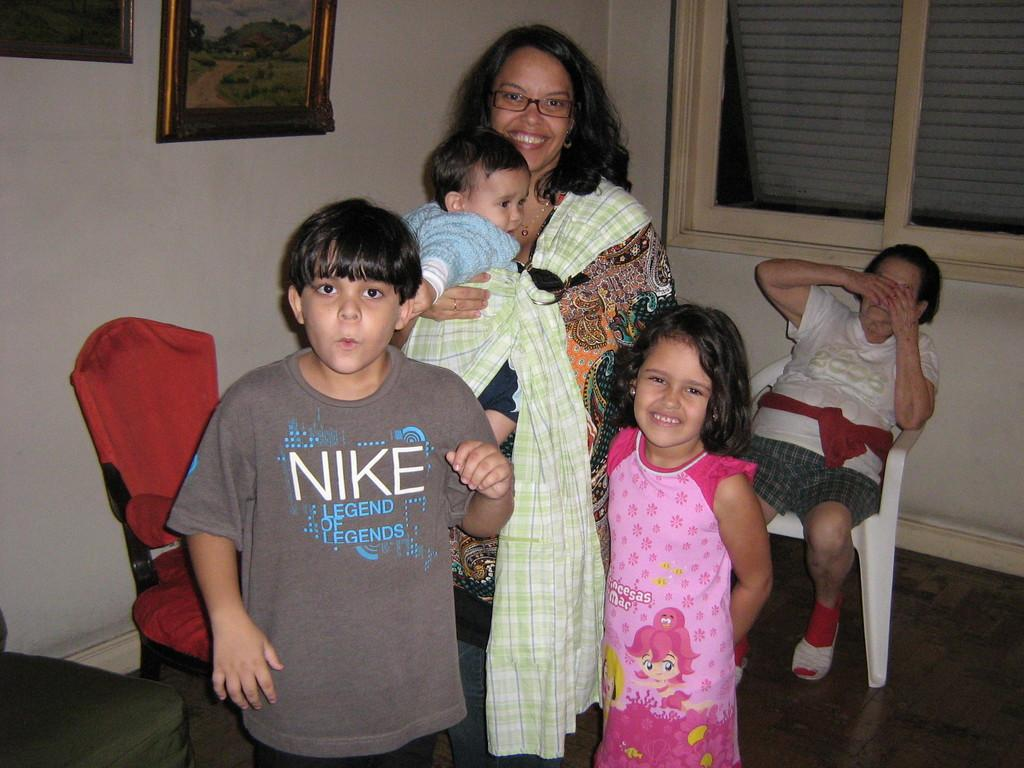How many people are in the image? There are people in the image, but the exact number is not specified. What can be seen in the background of the image? In the background of the image, there is a wall, chairs, a frame, windows, and other objects. Can you describe the object on the left side of the image? The object on the left side of the image is not specified in the facts. What might be used for sitting or resting in the image? Chairs are present in the background of the image, which might be used for sitting or resting. What type of oatmeal is being served on the table in the image? There is no table or oatmeal present in the image. What color is the tail of the animal in the image? There is no animal with a tail present in the image. 